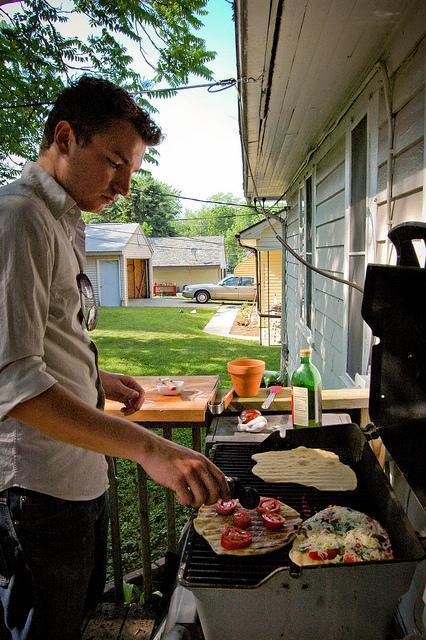How many pizzas are there?
Give a very brief answer. 3. 